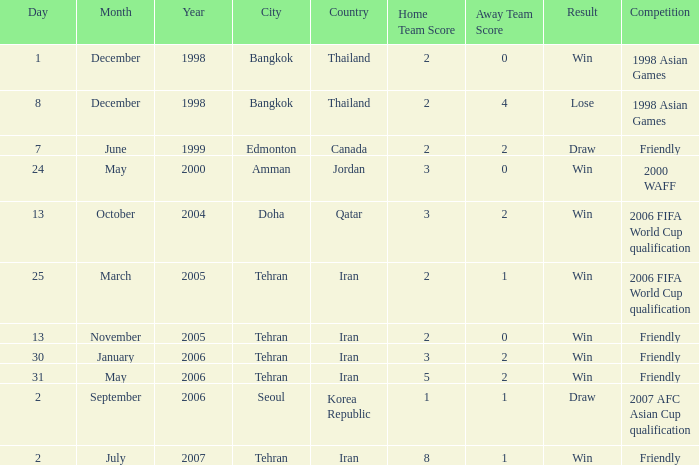Can you parse all the data within this table? {'header': ['Day', 'Month', 'Year', 'City', 'Country', 'Home Team Score', 'Away Team Score', 'Result', 'Competition'], 'rows': [['1', 'December', '1998', 'Bangkok', 'Thailand', '2', '0', 'Win', '1998 Asian Games'], ['8', 'December', '1998', 'Bangkok', 'Thailand', '2', '4', 'Lose', '1998 Asian Games'], ['7', 'June', '1999', 'Edmonton', 'Canada', '2', '2', 'Draw', 'Friendly'], ['24', 'May', '2000', 'Amman', 'Jordan', '3', '0', 'Win', '2000 WAFF'], ['13', 'October', '2004', 'Doha', 'Qatar', '3', '2', 'Win', '2006 FIFA World Cup qualification'], ['25', 'March', '2005', 'Tehran', 'Iran', '2', '1', 'Win', '2006 FIFA World Cup qualification'], ['13', 'November', '2005', 'Tehran', 'Iran', '2', '0', 'Win', 'Friendly'], ['30', 'January', '2006', 'Tehran', 'Iran', '3', '2', 'Win', 'Friendly'], ['31', 'May', '2006', 'Tehran', 'Iran', '5', '2', 'Win', 'Friendly'], ['2', 'September', '2006', 'Seoul', 'Korea Republic', '1', '1', 'Draw', '2007 AFC Asian Cup qualification'], ['2', 'July', '2007', 'Tehran', 'Iran', '8', '1', 'Win', 'Friendly']]} On june 7, 1999, which competition occurred? Friendly. 